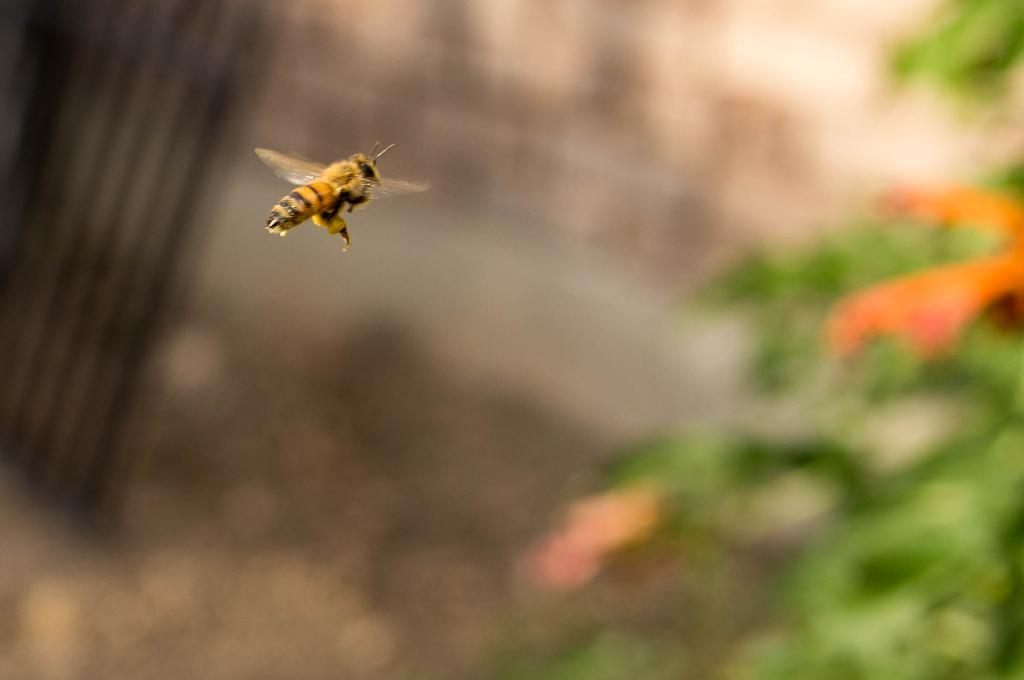What is the main subject of the image? There is a bee in the image. What is the bee doing in the image? The bee is flying in the air. Can you describe the background of the image? The background of the image is blurry. What type of hat is the bee wearing in the image? There is no hat present on the bee in the image. Is there any poison visible in the image? There is no poison present in the image. How many dimes can be seen in the image? There are no dimes present in the image. 